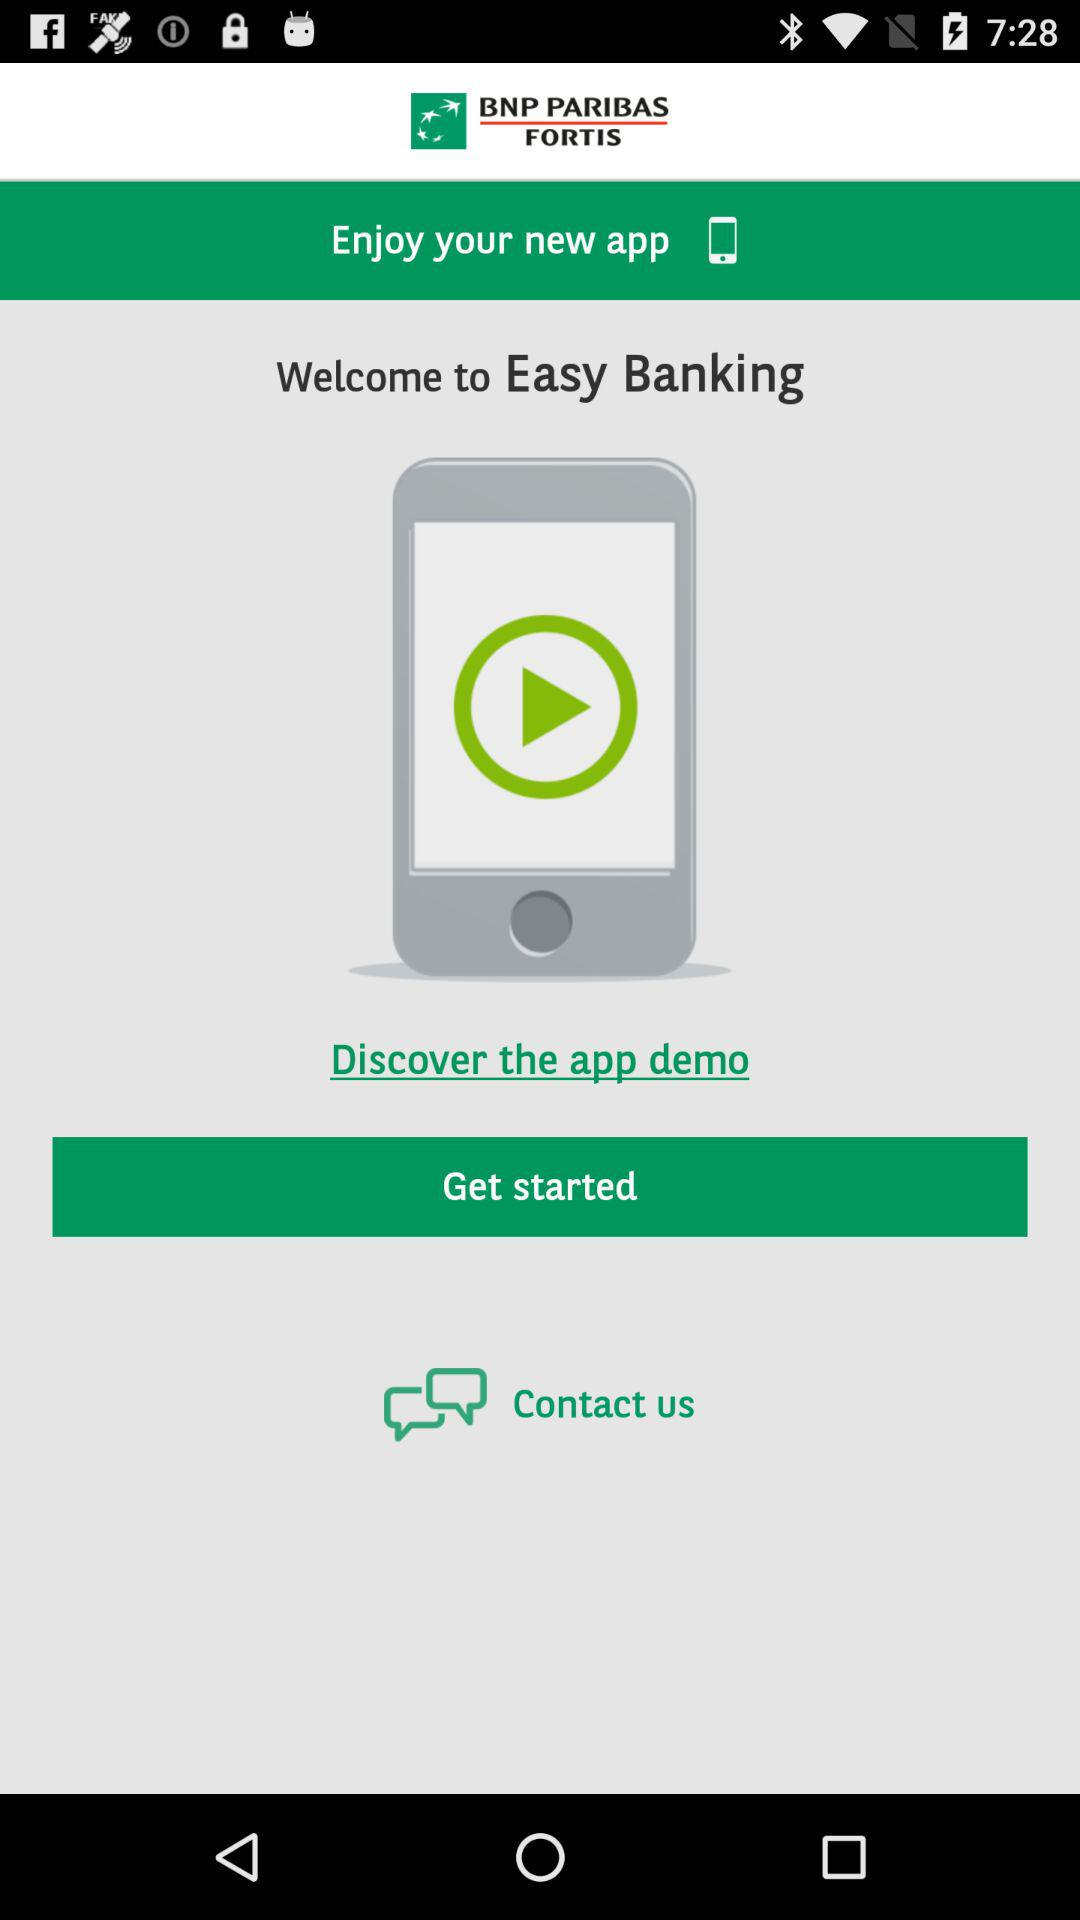What is the application name? The application name is "Easy Banking". 